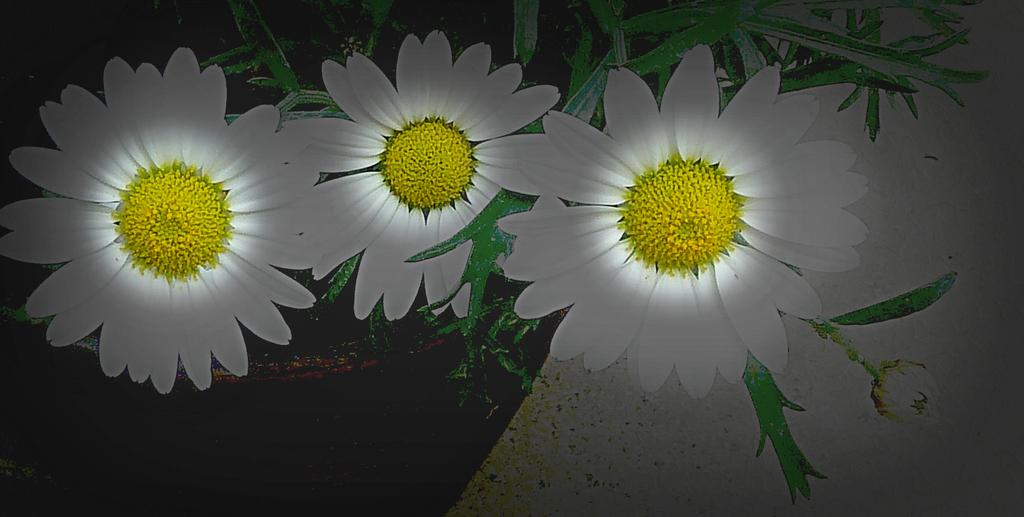What type of living organisms can be seen in the image? There are flowers in the image. Where are the flowers located? The flowers are on a plant. What colors are the flowers in the image? The flowers are in white and yellow colors. Can you tell me how the flowers are causing trouble in the image? There is no indication in the image that the flowers are causing trouble; they are simply flowers on a plant. 